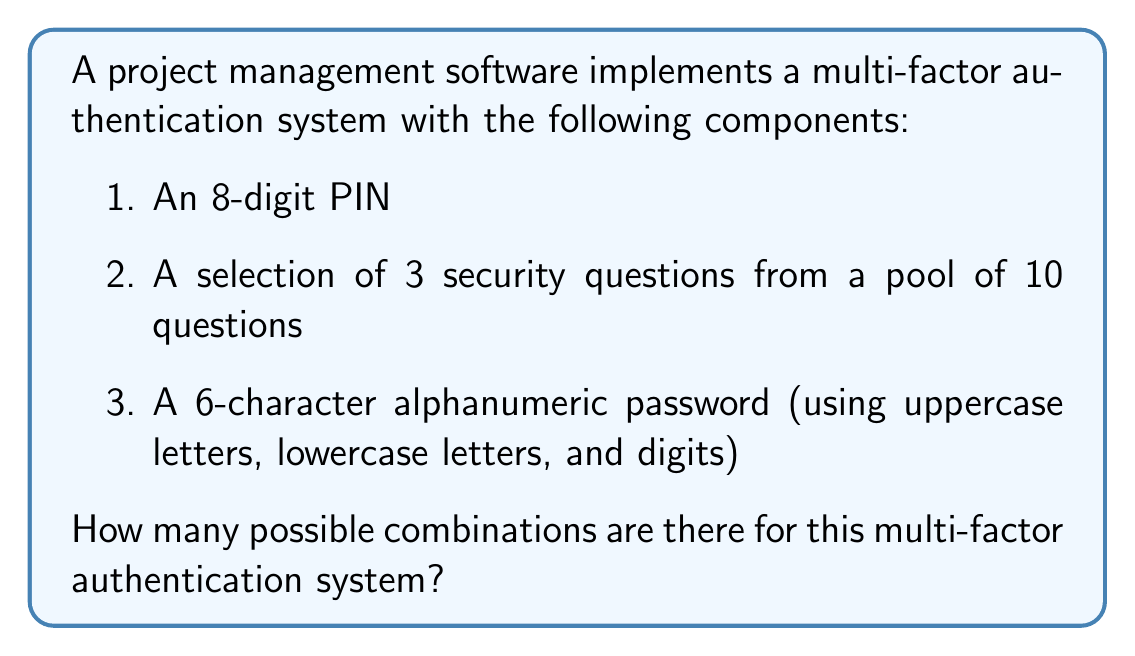What is the answer to this math problem? Let's break this down step-by-step:

1. 8-digit PIN:
   - Each digit can be any number from 0 to 9
   - Total combinations = $10^8$

2. Security questions:
   - We need to select 3 questions out of 10
   - This is a combination problem, calculated as $\binom{10}{3}$
   - $\binom{10}{3} = \frac{10!}{3!(10-3)!} = \frac{10!}{3!7!} = 120$

3. 6-character alphanumeric password:
   - We can use uppercase letters (26), lowercase letters (26), and digits (10)
   - Total characters available = 26 + 26 + 10 = 62
   - For each of the 6 positions, we have 62 choices
   - Total combinations = $62^6$

To get the total number of possible combinations, we multiply these together:

$$ \text{Total Combinations} = 10^8 \times 120 \times 62^6 $$

Calculating this:
$$ 10^8 \times 120 \times 62^6 = 100,000,000 \times 120 \times 56,800,235,584 $$
$$ = 681,602,827,008,000,000,000 $$

This can be expressed in scientific notation as $6.816 \times 10^{20}$.
Answer: $6.816 \times 10^{20}$ 